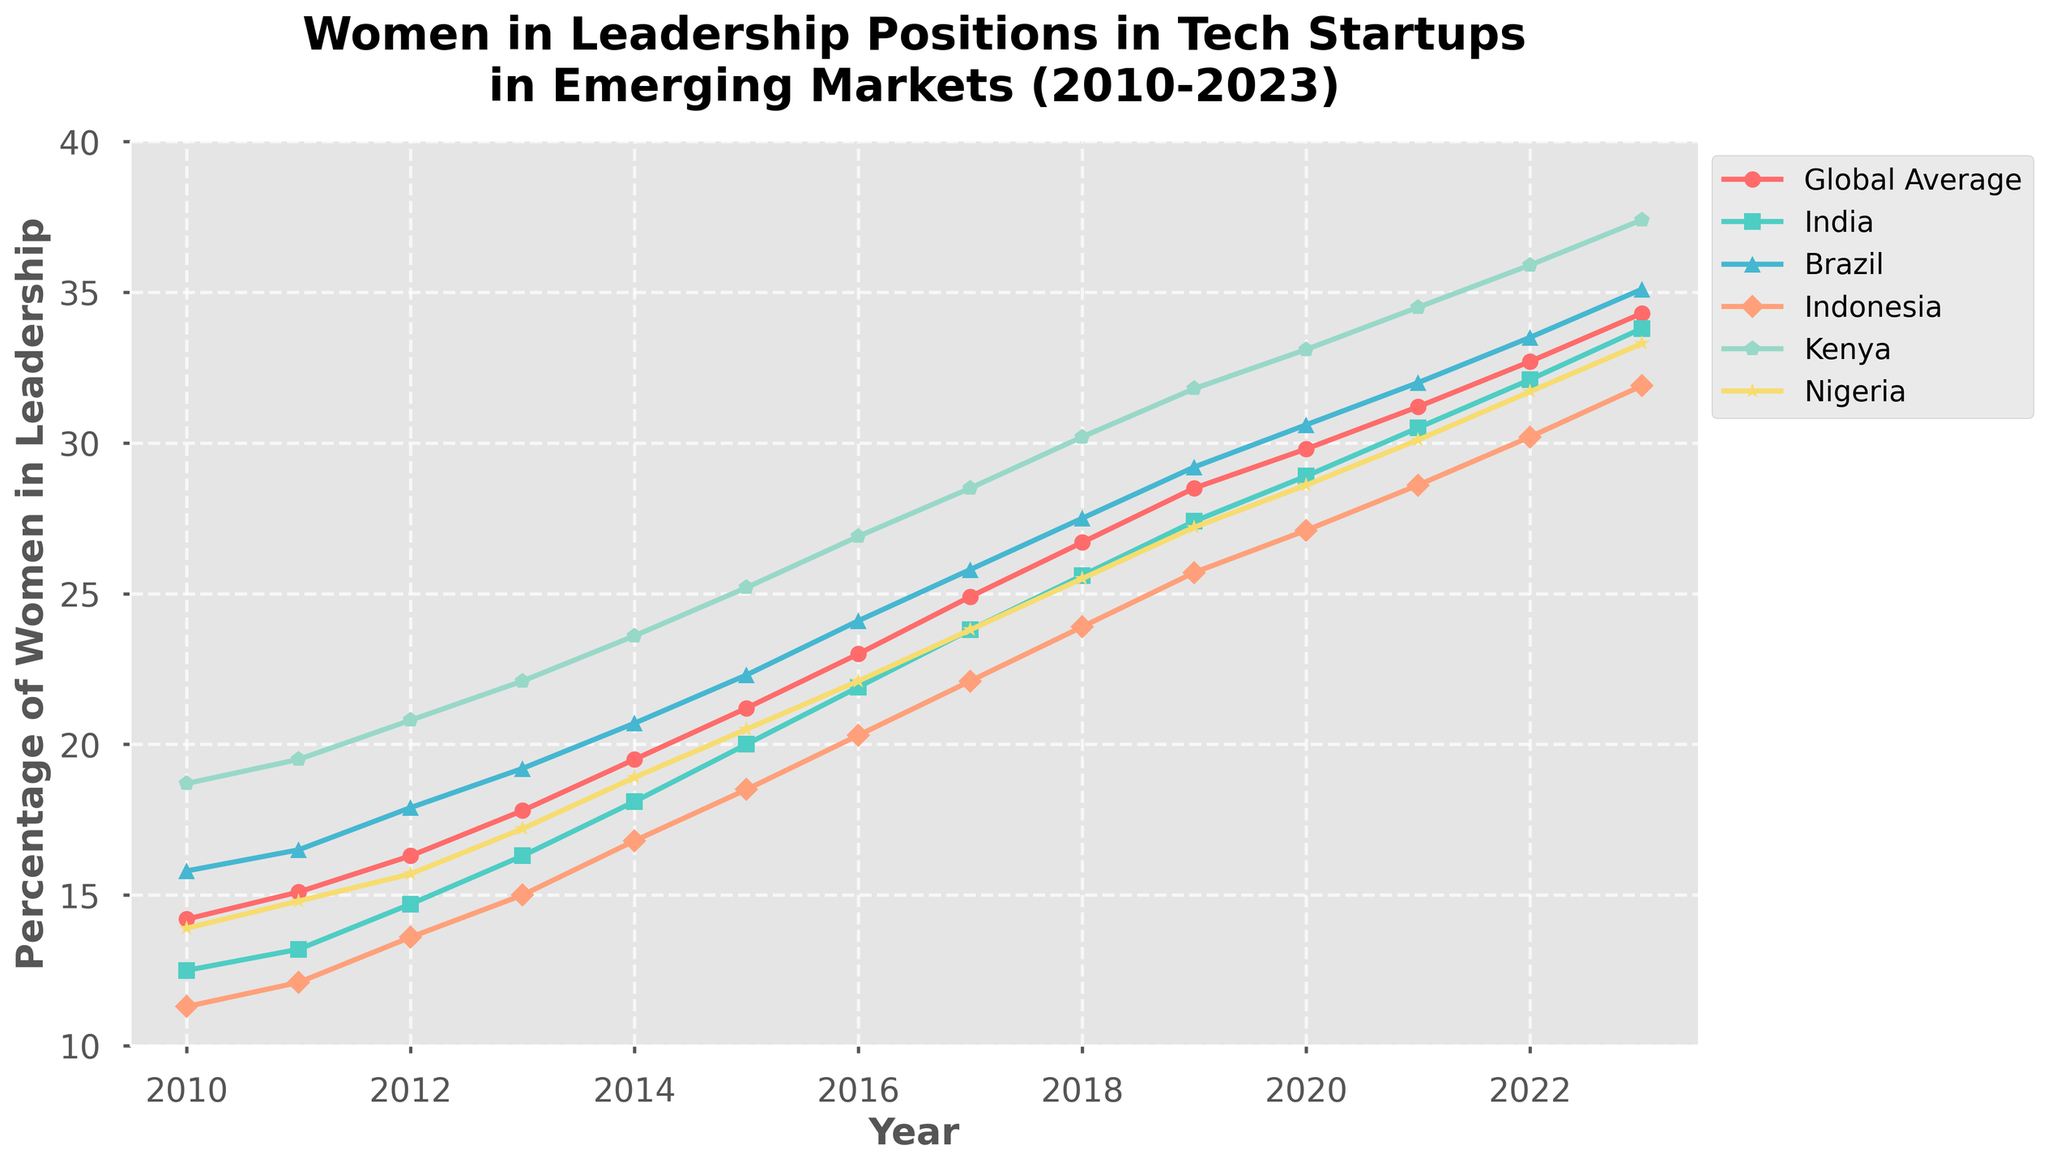What trend do you observe for the percentage of women in leadership positions in Kenya from 2010 to 2023? To identify the trend, look at the line representing Kenya. It starts at 18.7% in 2010 and shows a steady increase to 37.4% in 2023.
Answer: Increasing trend Which country had the highest percentage of women in leadership positions in 2023? Check the endpoints of each line in the year 2023. The line representing Kenya ends at the highest point, 37.4%.
Answer: Kenya Which country showed the largest increase in the percentage of women in leadership positions between 2010 and 2023? Calculate the difference between 2023 and 2010 values for each country. Kenya increases by (37.4% - 18.7% = 18.7%), which is the largest increase among all the countries.
Answer: Kenya By how much did the global average percentage of women in leadership positions change from 2010 to 2023? Subtract the global average percentage in 2010 from that in 2023: 34.3% - 14.2% = 20.1%.
Answer: 20.1% In which year did Indonesia surpass the global average for women in leadership positions? Compare the lines for Indonesia and the global average. Indonesia surpasses the global average in 2019.
Answer: 2019 Which market witnessed the smallest increase in women's leadership percentage from 2010 to 2023? Calculate the change for each country. Nigeria's increase is the smallest: (33.3% - 13.9% = 19.4%).
Answer: Nigeria What is the average percentage of women in leadership positions in Brazil during the entire period? Sum the values for Brazil and divide by the number of years: (15.8+16.5+17.9+19.2+20.7+22.3+24.1+25.8+27.5+29.2+30.6+32.0+33.5+35.1) / 14 = 24.14%.
Answer: 24.14% By how much did the percentage of women in leadership positions in India change from 2015 to 2018? Subtract the 2015 value from the 2018 value for India: 25.6% - 20.0% = 5.6%.
Answer: 5.6% Which country had a steeper increase in women leadership percentages from 2012 to 2016: Nigeria or India? Calculate the change from 2012 to 2016 for Nigeria (22.1% - 15.7% = 6.4%) and for India (21.9% - 14.7% = 7.2%). India's increase is steeper.
Answer: India 